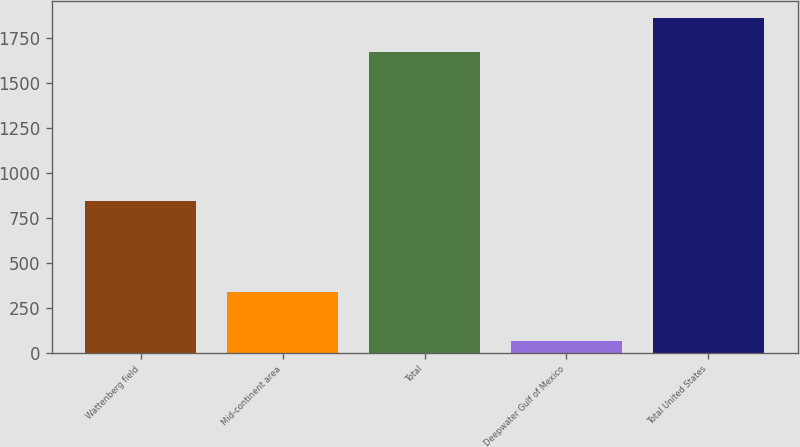<chart> <loc_0><loc_0><loc_500><loc_500><bar_chart><fcel>Wattenberg field<fcel>Mid-continent area<fcel>Total<fcel>Deepwater Gulf of Mexico<fcel>Total United States<nl><fcel>842<fcel>336<fcel>1672<fcel>64<fcel>1859<nl></chart> 